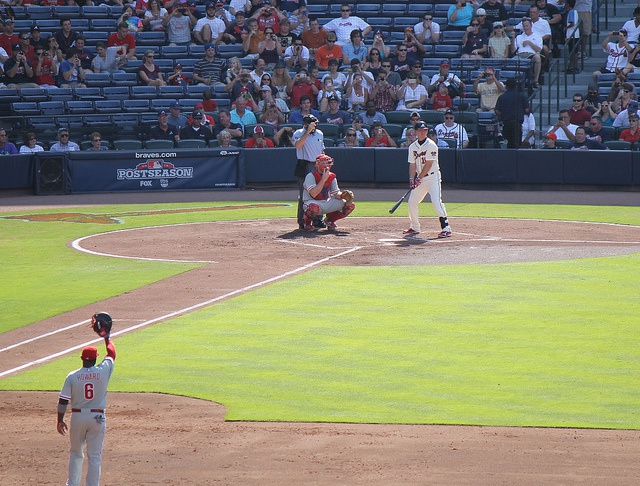Describe the objects in this image and their specific colors. I can see people in black, gray, navy, and darkblue tones, people in black and gray tones, people in black, darkgray, lightgray, and brown tones, people in black, gray, maroon, brown, and darkgray tones, and people in black, gray, and purple tones in this image. 